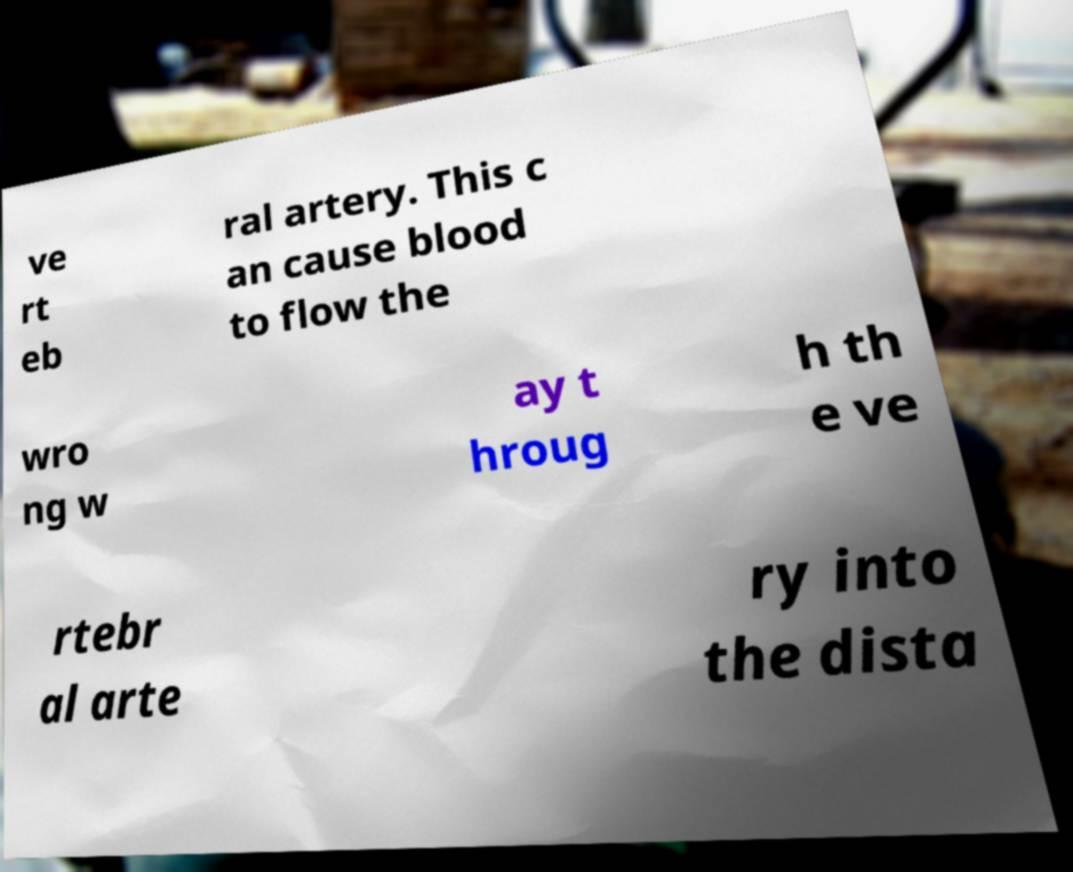For documentation purposes, I need the text within this image transcribed. Could you provide that? ve rt eb ral artery. This c an cause blood to flow the wro ng w ay t hroug h th e ve rtebr al arte ry into the dista 